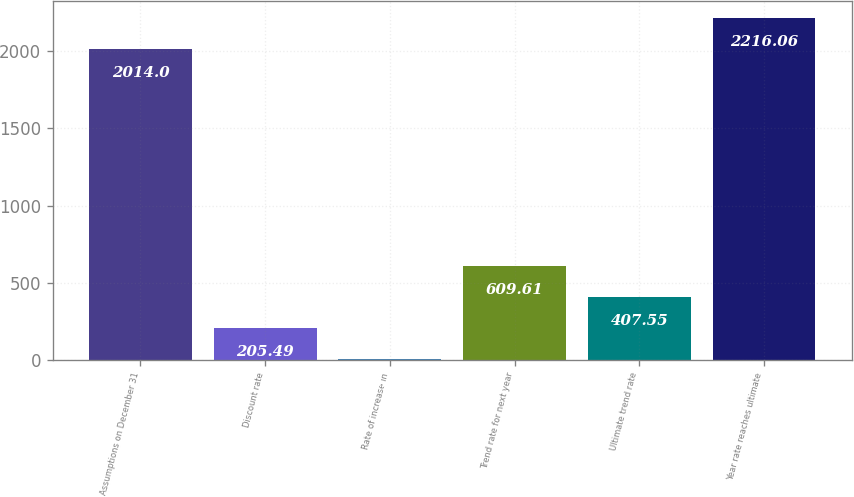<chart> <loc_0><loc_0><loc_500><loc_500><bar_chart><fcel>Assumptions on December 31<fcel>Discount rate<fcel>Rate of increase in<fcel>Trend rate for next year<fcel>Ultimate trend rate<fcel>Year rate reaches ultimate<nl><fcel>2014<fcel>205.49<fcel>3.43<fcel>609.61<fcel>407.55<fcel>2216.06<nl></chart> 